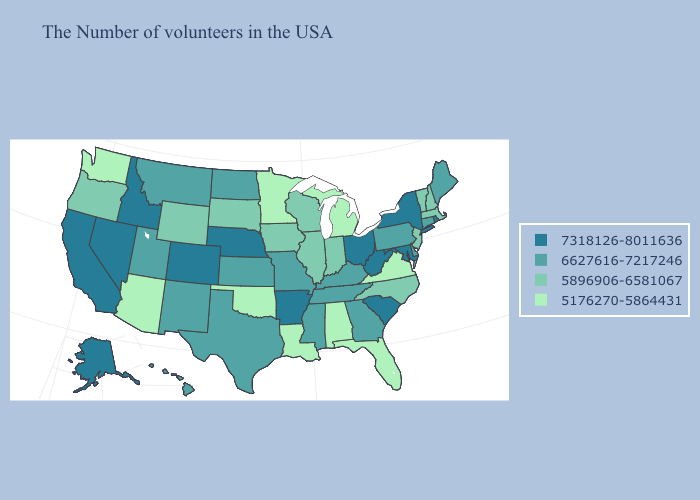Which states have the highest value in the USA?
Quick response, please. Rhode Island, New York, Maryland, South Carolina, West Virginia, Ohio, Arkansas, Nebraska, Colorado, Idaho, Nevada, California, Alaska. Does Washington have the lowest value in the USA?
Quick response, please. Yes. Name the states that have a value in the range 7318126-8011636?
Keep it brief. Rhode Island, New York, Maryland, South Carolina, West Virginia, Ohio, Arkansas, Nebraska, Colorado, Idaho, Nevada, California, Alaska. Among the states that border Alabama , does Florida have the highest value?
Short answer required. No. Does North Carolina have the same value as Louisiana?
Short answer required. No. What is the value of Ohio?
Be succinct. 7318126-8011636. Does Arizona have the highest value in the USA?
Answer briefly. No. Does the map have missing data?
Answer briefly. No. Does Illinois have the highest value in the MidWest?
Be succinct. No. Name the states that have a value in the range 5176270-5864431?
Keep it brief. Virginia, Florida, Michigan, Alabama, Louisiana, Minnesota, Oklahoma, Arizona, Washington. Name the states that have a value in the range 5176270-5864431?
Answer briefly. Virginia, Florida, Michigan, Alabama, Louisiana, Minnesota, Oklahoma, Arizona, Washington. Which states have the highest value in the USA?
Short answer required. Rhode Island, New York, Maryland, South Carolina, West Virginia, Ohio, Arkansas, Nebraska, Colorado, Idaho, Nevada, California, Alaska. What is the highest value in the Northeast ?
Give a very brief answer. 7318126-8011636. Does South Dakota have the lowest value in the USA?
Answer briefly. No. What is the lowest value in the Northeast?
Give a very brief answer. 5896906-6581067. 